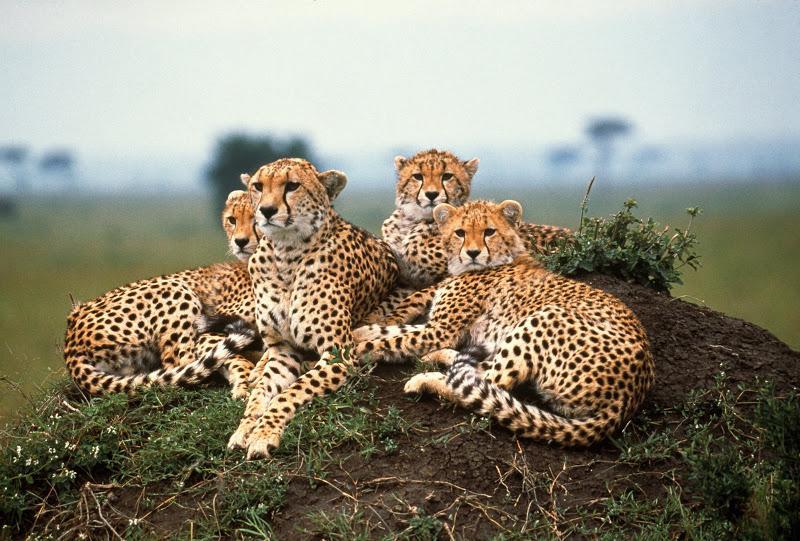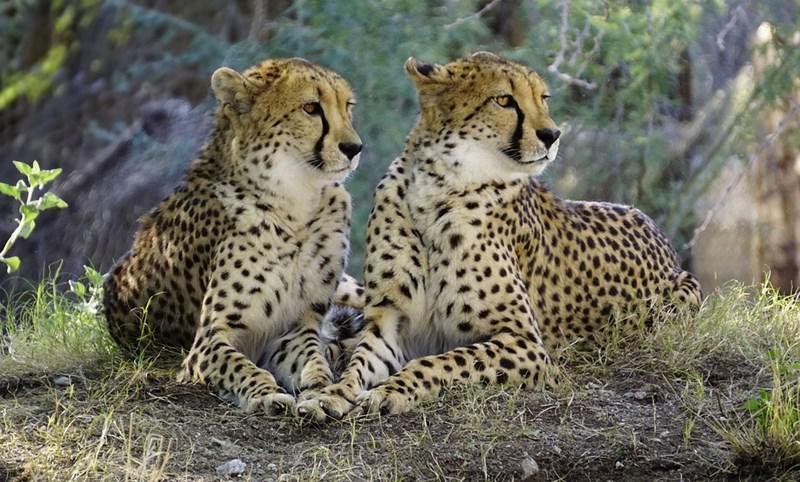The first image is the image on the left, the second image is the image on the right. Analyze the images presented: Is the assertion "There are four leopard’s sitting on a mound of dirt." valid? Answer yes or no. Yes. The first image is the image on the left, the second image is the image on the right. Considering the images on both sides, is "Exactly six of the big cats are resting, keeping an eye on their surroundings." valid? Answer yes or no. Yes. 